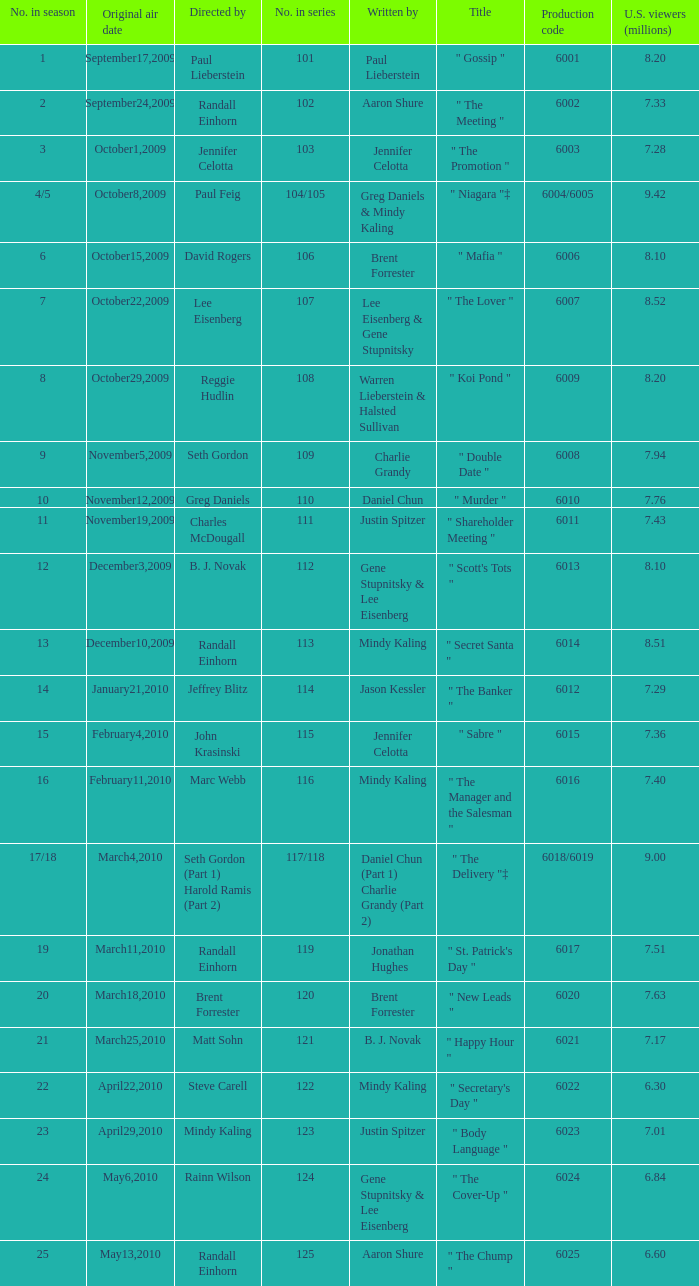Name the production code for number in season being 21 6021.0. 